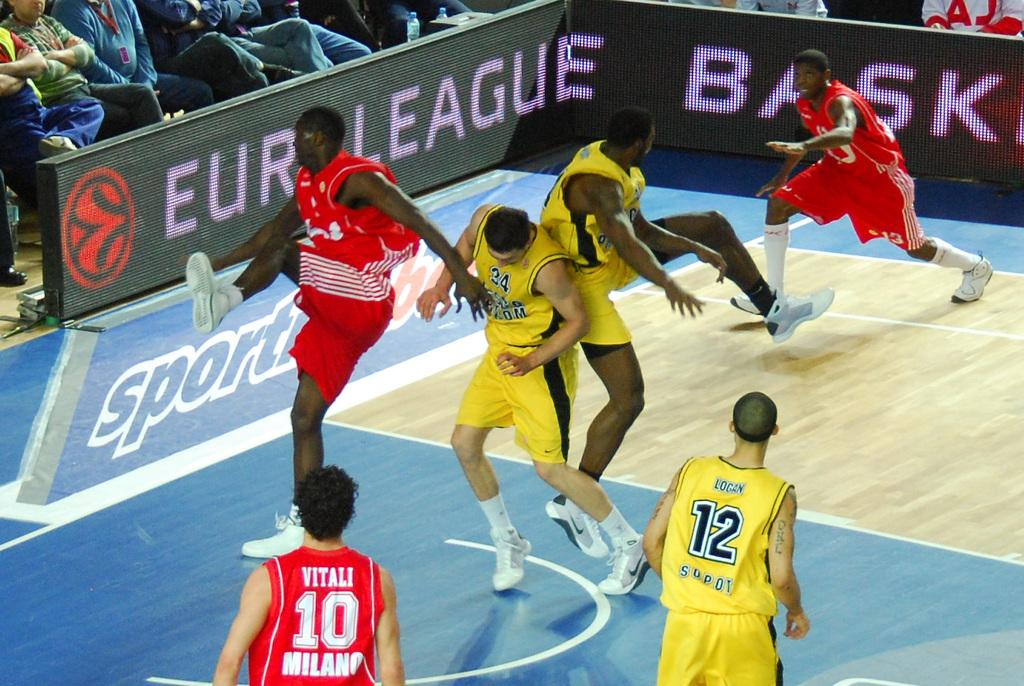<image>
Create a compact narrative representing the image presented. A few basketball players colliding at a Euro League Basketball game. 